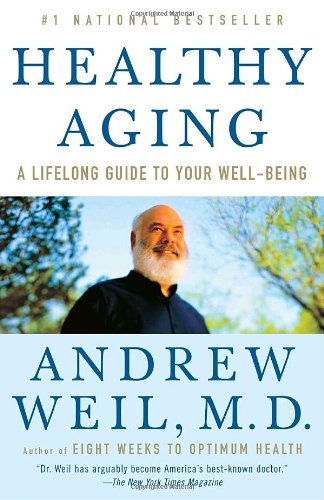Is this a homosexuality book? No, this book does not discuss topics related to homosexuality; it focuses primarily on aspects of healthy aging and lifestyle management for well-being. 